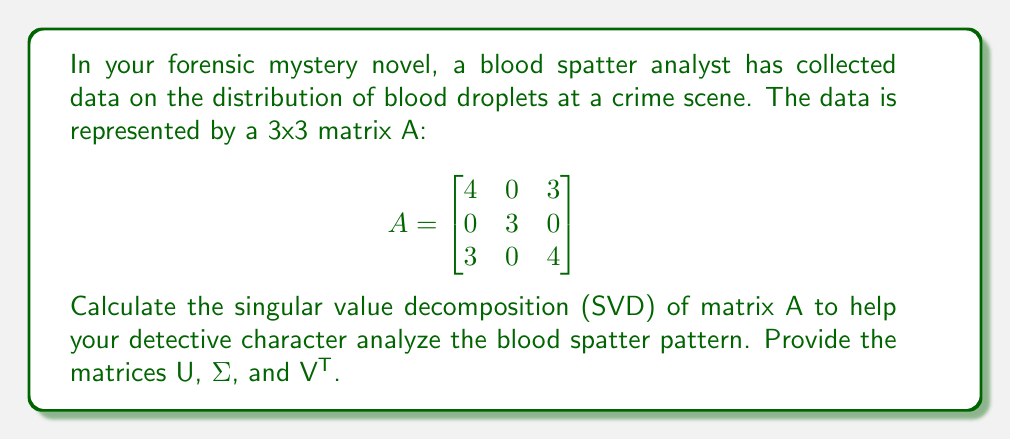Can you solve this math problem? To find the singular value decomposition (SVD) of matrix A, we need to follow these steps:

1. Calculate A^T A and AA^T:
   $$A^T A = \begin{bmatrix}
   25 & 0 & 24\\
   0 & 9 & 0\\
   24 & 0 & 25
   \end{bmatrix}$$
   
   $$AA^T = \begin{bmatrix}
   25 & 0 & 24\\
   0 & 9 & 0\\
   24 & 0 & 25
   \end{bmatrix}$$

2. Find the eigenvalues of A^T A (which are the same as AA^T):
   Characteristic equation: $(\lambda - 9)(\lambda^2 - 50\lambda + 49) = 0$
   Eigenvalues: $\lambda_1 = 49, \lambda_2 = 9, \lambda_3 = 1$

3. Calculate the singular values (σ_i = √λ_i):
   $\sigma_1 = 7, \sigma_2 = 3, \sigma_3 = 1$

4. Find the eigenvectors of A^T A to form V:
   For λ_1 = 49: $\vec{v_1} = \frac{1}{\sqrt{2}}[1, 0, 1]^T$
   For λ_2 = 9:  $\vec{v_2} = [0, 1, 0]^T$
   For λ_3 = 1:  $\vec{v_3} = \frac{1}{\sqrt{2}}[-1, 0, 1]^T$

5. Find the eigenvectors of AA^T to form U:
   For λ_1 = 49: $\vec{u_1} = \frac{1}{\sqrt{2}}[1, 0, 1]^T$
   For λ_2 = 9:  $\vec{u_2} = [0, 1, 0]^T$
   For λ_3 = 1:  $\vec{u_3} = \frac{1}{\sqrt{2}}[-1, 0, 1]^T$

6. Construct the matrices U, Σ, and V^T:

   $$U = \begin{bmatrix}
   \frac{1}{\sqrt{2}} & 0 & -\frac{1}{\sqrt{2}}\\
   0 & 1 & 0\\
   \frac{1}{\sqrt{2}} & 0 & \frac{1}{\sqrt{2}}
   \end{bmatrix}$$

   $$\Sigma = \begin{bmatrix}
   7 & 0 & 0\\
   0 & 3 & 0\\
   0 & 0 & 1
   \end{bmatrix}$$

   $$V^T = \begin{bmatrix}
   \frac{1}{\sqrt{2}} & 0 & \frac{1}{\sqrt{2}}\\
   0 & 1 & 0\\
   -\frac{1}{\sqrt{2}} & 0 & \frac{1}{\sqrt{2}}
   \end{bmatrix}$$
Answer: $$U = \begin{bmatrix}
\frac{1}{\sqrt{2}} & 0 & -\frac{1}{\sqrt{2}}\\
0 & 1 & 0\\
\frac{1}{\sqrt{2}} & 0 & \frac{1}{\sqrt{2}}
\end{bmatrix}, \Sigma = \begin{bmatrix}
7 & 0 & 0\\
0 & 3 & 0\\
0 & 0 & 1
\end{bmatrix}, V^T = \begin{bmatrix}
\frac{1}{\sqrt{2}} & 0 & \frac{1}{\sqrt{2}}\\
0 & 1 & 0\\
-\frac{1}{\sqrt{2}} & 0 & \frac{1}{\sqrt{2}}
\end{bmatrix}$$ 